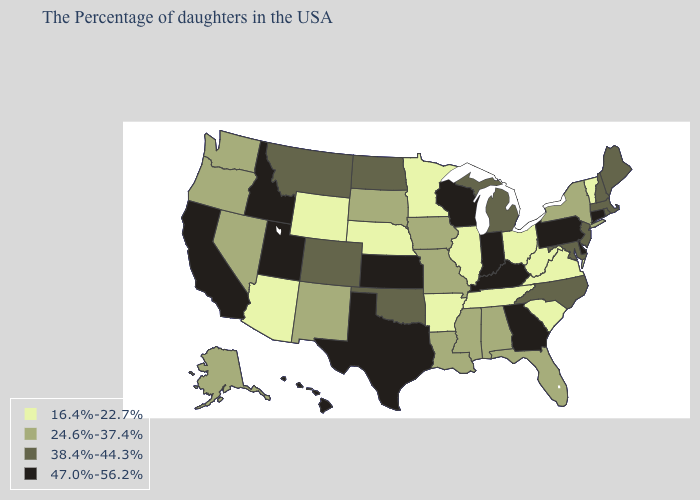Does Arizona have a higher value than Montana?
Keep it brief. No. Name the states that have a value in the range 38.4%-44.3%?
Concise answer only. Maine, Massachusetts, Rhode Island, New Hampshire, New Jersey, Maryland, North Carolina, Michigan, Oklahoma, North Dakota, Colorado, Montana. Which states have the highest value in the USA?
Keep it brief. Connecticut, Delaware, Pennsylvania, Georgia, Kentucky, Indiana, Wisconsin, Kansas, Texas, Utah, Idaho, California, Hawaii. What is the value of Kentucky?
Answer briefly. 47.0%-56.2%. Is the legend a continuous bar?
Answer briefly. No. Does South Carolina have the same value as Arkansas?
Quick response, please. Yes. How many symbols are there in the legend?
Keep it brief. 4. Does Illinois have the highest value in the MidWest?
Short answer required. No. What is the highest value in states that border Texas?
Concise answer only. 38.4%-44.3%. Which states have the lowest value in the USA?
Keep it brief. Vermont, Virginia, South Carolina, West Virginia, Ohio, Tennessee, Illinois, Arkansas, Minnesota, Nebraska, Wyoming, Arizona. What is the value of Colorado?
Write a very short answer. 38.4%-44.3%. Does Pennsylvania have the highest value in the Northeast?
Concise answer only. Yes. Does the first symbol in the legend represent the smallest category?
Answer briefly. Yes. Which states have the lowest value in the USA?
Concise answer only. Vermont, Virginia, South Carolina, West Virginia, Ohio, Tennessee, Illinois, Arkansas, Minnesota, Nebraska, Wyoming, Arizona. Does Rhode Island have a higher value than Kentucky?
Write a very short answer. No. 